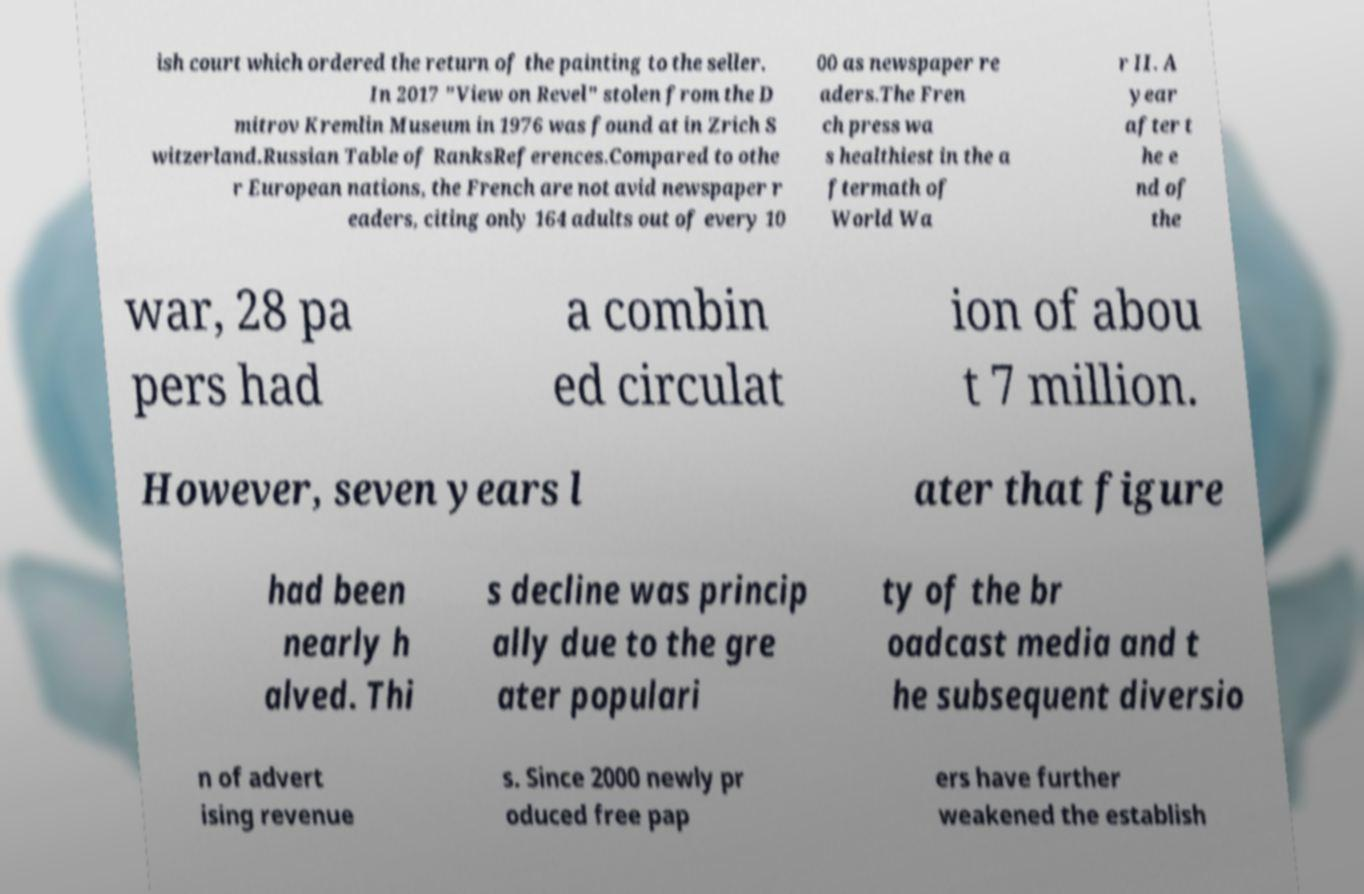I need the written content from this picture converted into text. Can you do that? ish court which ordered the return of the painting to the seller. In 2017 "View on Revel" stolen from the D mitrov Kremlin Museum in 1976 was found at in Zrich S witzerland.Russian Table of RanksReferences.Compared to othe r European nations, the French are not avid newspaper r eaders, citing only 164 adults out of every 10 00 as newspaper re aders.The Fren ch press wa s healthiest in the a ftermath of World Wa r II. A year after t he e nd of the war, 28 pa pers had a combin ed circulat ion of abou t 7 million. However, seven years l ater that figure had been nearly h alved. Thi s decline was princip ally due to the gre ater populari ty of the br oadcast media and t he subsequent diversio n of advert ising revenue s. Since 2000 newly pr oduced free pap ers have further weakened the establish 